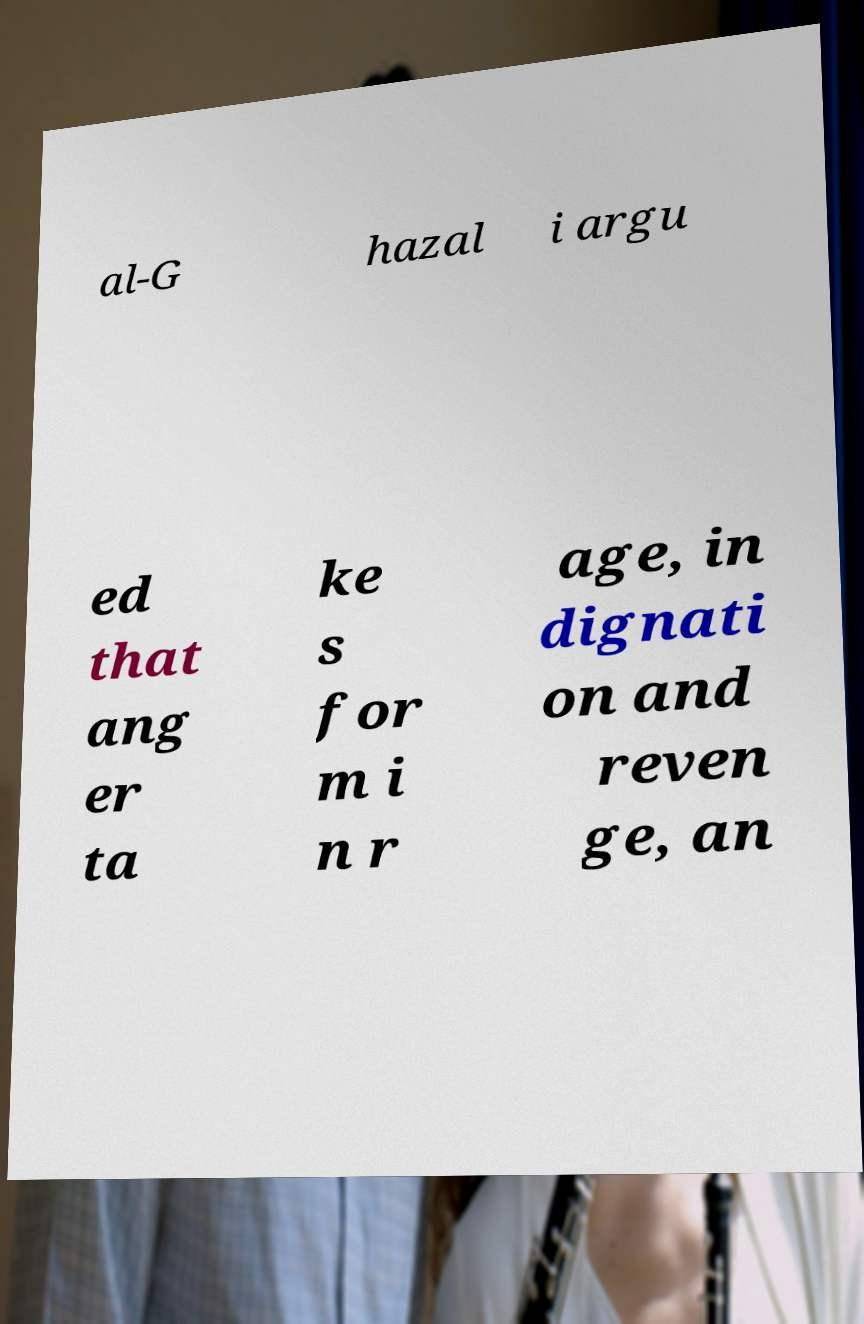Could you extract and type out the text from this image? al-G hazal i argu ed that ang er ta ke s for m i n r age, in dignati on and reven ge, an 